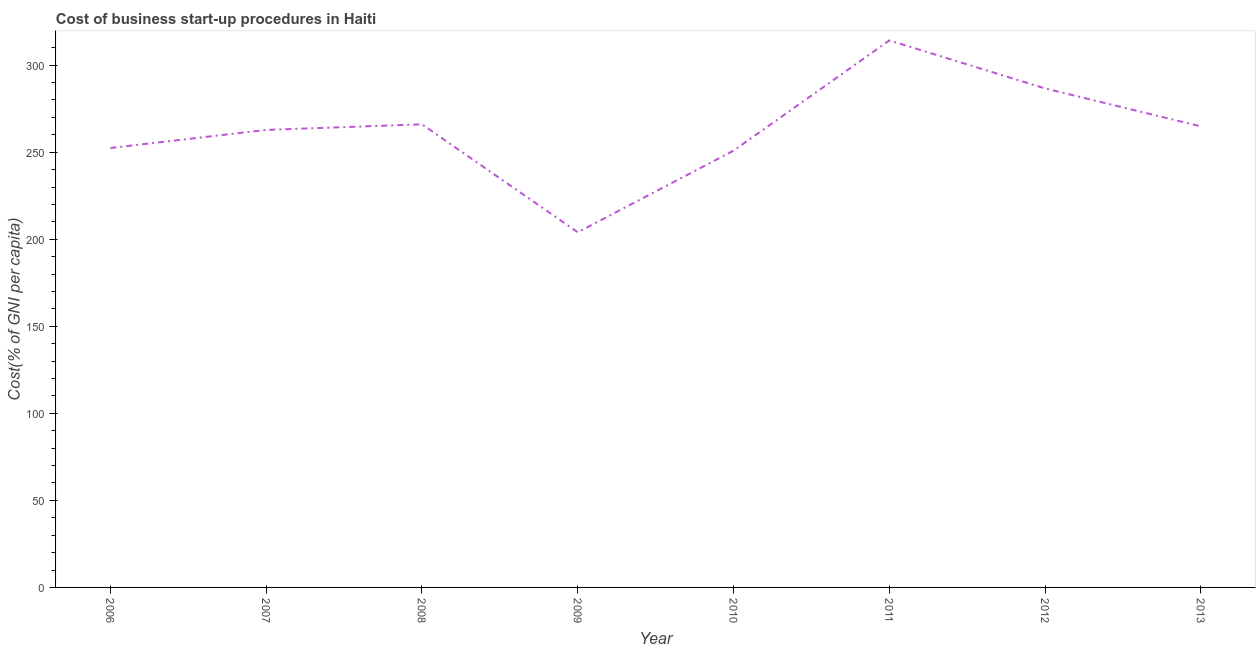What is the cost of business startup procedures in 2008?
Keep it short and to the point. 266. Across all years, what is the maximum cost of business startup procedures?
Provide a succinct answer. 314.2. Across all years, what is the minimum cost of business startup procedures?
Offer a terse response. 204. In which year was the cost of business startup procedures minimum?
Give a very brief answer. 2009. What is the sum of the cost of business startup procedures?
Provide a succinct answer. 2101.7. What is the difference between the cost of business startup procedures in 2007 and 2013?
Offer a terse response. -2. What is the average cost of business startup procedures per year?
Your response must be concise. 262.71. What is the median cost of business startup procedures?
Your response must be concise. 263.8. What is the ratio of the cost of business startup procedures in 2006 to that in 2007?
Provide a short and direct response. 0.96. Is the cost of business startup procedures in 2006 less than that in 2010?
Your answer should be compact. No. Is the difference between the cost of business startup procedures in 2008 and 2010 greater than the difference between any two years?
Your answer should be very brief. No. What is the difference between the highest and the second highest cost of business startup procedures?
Offer a terse response. 27.6. What is the difference between the highest and the lowest cost of business startup procedures?
Keep it short and to the point. 110.2. How many years are there in the graph?
Your response must be concise. 8. What is the difference between two consecutive major ticks on the Y-axis?
Keep it short and to the point. 50. Does the graph contain any zero values?
Your response must be concise. No. What is the title of the graph?
Offer a very short reply. Cost of business start-up procedures in Haiti. What is the label or title of the X-axis?
Keep it short and to the point. Year. What is the label or title of the Y-axis?
Make the answer very short. Cost(% of GNI per capita). What is the Cost(% of GNI per capita) of 2006?
Provide a short and direct response. 252.4. What is the Cost(% of GNI per capita) of 2007?
Make the answer very short. 262.8. What is the Cost(% of GNI per capita) of 2008?
Provide a short and direct response. 266. What is the Cost(% of GNI per capita) in 2009?
Offer a very short reply. 204. What is the Cost(% of GNI per capita) of 2010?
Keep it short and to the point. 250.9. What is the Cost(% of GNI per capita) in 2011?
Offer a very short reply. 314.2. What is the Cost(% of GNI per capita) of 2012?
Make the answer very short. 286.6. What is the Cost(% of GNI per capita) in 2013?
Offer a terse response. 264.8. What is the difference between the Cost(% of GNI per capita) in 2006 and 2007?
Provide a short and direct response. -10.4. What is the difference between the Cost(% of GNI per capita) in 2006 and 2009?
Give a very brief answer. 48.4. What is the difference between the Cost(% of GNI per capita) in 2006 and 2010?
Your answer should be compact. 1.5. What is the difference between the Cost(% of GNI per capita) in 2006 and 2011?
Your response must be concise. -61.8. What is the difference between the Cost(% of GNI per capita) in 2006 and 2012?
Offer a terse response. -34.2. What is the difference between the Cost(% of GNI per capita) in 2006 and 2013?
Your response must be concise. -12.4. What is the difference between the Cost(% of GNI per capita) in 2007 and 2008?
Your answer should be compact. -3.2. What is the difference between the Cost(% of GNI per capita) in 2007 and 2009?
Provide a succinct answer. 58.8. What is the difference between the Cost(% of GNI per capita) in 2007 and 2011?
Your answer should be compact. -51.4. What is the difference between the Cost(% of GNI per capita) in 2007 and 2012?
Your answer should be compact. -23.8. What is the difference between the Cost(% of GNI per capita) in 2007 and 2013?
Provide a succinct answer. -2. What is the difference between the Cost(% of GNI per capita) in 2008 and 2011?
Keep it short and to the point. -48.2. What is the difference between the Cost(% of GNI per capita) in 2008 and 2012?
Keep it short and to the point. -20.6. What is the difference between the Cost(% of GNI per capita) in 2009 and 2010?
Your answer should be very brief. -46.9. What is the difference between the Cost(% of GNI per capita) in 2009 and 2011?
Your answer should be compact. -110.2. What is the difference between the Cost(% of GNI per capita) in 2009 and 2012?
Your answer should be compact. -82.6. What is the difference between the Cost(% of GNI per capita) in 2009 and 2013?
Your answer should be very brief. -60.8. What is the difference between the Cost(% of GNI per capita) in 2010 and 2011?
Your answer should be very brief. -63.3. What is the difference between the Cost(% of GNI per capita) in 2010 and 2012?
Ensure brevity in your answer.  -35.7. What is the difference between the Cost(% of GNI per capita) in 2010 and 2013?
Ensure brevity in your answer.  -13.9. What is the difference between the Cost(% of GNI per capita) in 2011 and 2012?
Your answer should be compact. 27.6. What is the difference between the Cost(% of GNI per capita) in 2011 and 2013?
Offer a terse response. 49.4. What is the difference between the Cost(% of GNI per capita) in 2012 and 2013?
Make the answer very short. 21.8. What is the ratio of the Cost(% of GNI per capita) in 2006 to that in 2007?
Provide a succinct answer. 0.96. What is the ratio of the Cost(% of GNI per capita) in 2006 to that in 2008?
Your answer should be very brief. 0.95. What is the ratio of the Cost(% of GNI per capita) in 2006 to that in 2009?
Offer a very short reply. 1.24. What is the ratio of the Cost(% of GNI per capita) in 2006 to that in 2011?
Make the answer very short. 0.8. What is the ratio of the Cost(% of GNI per capita) in 2006 to that in 2012?
Offer a very short reply. 0.88. What is the ratio of the Cost(% of GNI per capita) in 2006 to that in 2013?
Your answer should be very brief. 0.95. What is the ratio of the Cost(% of GNI per capita) in 2007 to that in 2008?
Provide a succinct answer. 0.99. What is the ratio of the Cost(% of GNI per capita) in 2007 to that in 2009?
Provide a short and direct response. 1.29. What is the ratio of the Cost(% of GNI per capita) in 2007 to that in 2010?
Provide a short and direct response. 1.05. What is the ratio of the Cost(% of GNI per capita) in 2007 to that in 2011?
Offer a terse response. 0.84. What is the ratio of the Cost(% of GNI per capita) in 2007 to that in 2012?
Offer a very short reply. 0.92. What is the ratio of the Cost(% of GNI per capita) in 2008 to that in 2009?
Give a very brief answer. 1.3. What is the ratio of the Cost(% of GNI per capita) in 2008 to that in 2010?
Give a very brief answer. 1.06. What is the ratio of the Cost(% of GNI per capita) in 2008 to that in 2011?
Provide a succinct answer. 0.85. What is the ratio of the Cost(% of GNI per capita) in 2008 to that in 2012?
Provide a short and direct response. 0.93. What is the ratio of the Cost(% of GNI per capita) in 2008 to that in 2013?
Offer a very short reply. 1. What is the ratio of the Cost(% of GNI per capita) in 2009 to that in 2010?
Keep it short and to the point. 0.81. What is the ratio of the Cost(% of GNI per capita) in 2009 to that in 2011?
Give a very brief answer. 0.65. What is the ratio of the Cost(% of GNI per capita) in 2009 to that in 2012?
Offer a terse response. 0.71. What is the ratio of the Cost(% of GNI per capita) in 2009 to that in 2013?
Your response must be concise. 0.77. What is the ratio of the Cost(% of GNI per capita) in 2010 to that in 2011?
Make the answer very short. 0.8. What is the ratio of the Cost(% of GNI per capita) in 2010 to that in 2012?
Keep it short and to the point. 0.88. What is the ratio of the Cost(% of GNI per capita) in 2010 to that in 2013?
Provide a short and direct response. 0.95. What is the ratio of the Cost(% of GNI per capita) in 2011 to that in 2012?
Offer a very short reply. 1.1. What is the ratio of the Cost(% of GNI per capita) in 2011 to that in 2013?
Ensure brevity in your answer.  1.19. What is the ratio of the Cost(% of GNI per capita) in 2012 to that in 2013?
Provide a short and direct response. 1.08. 